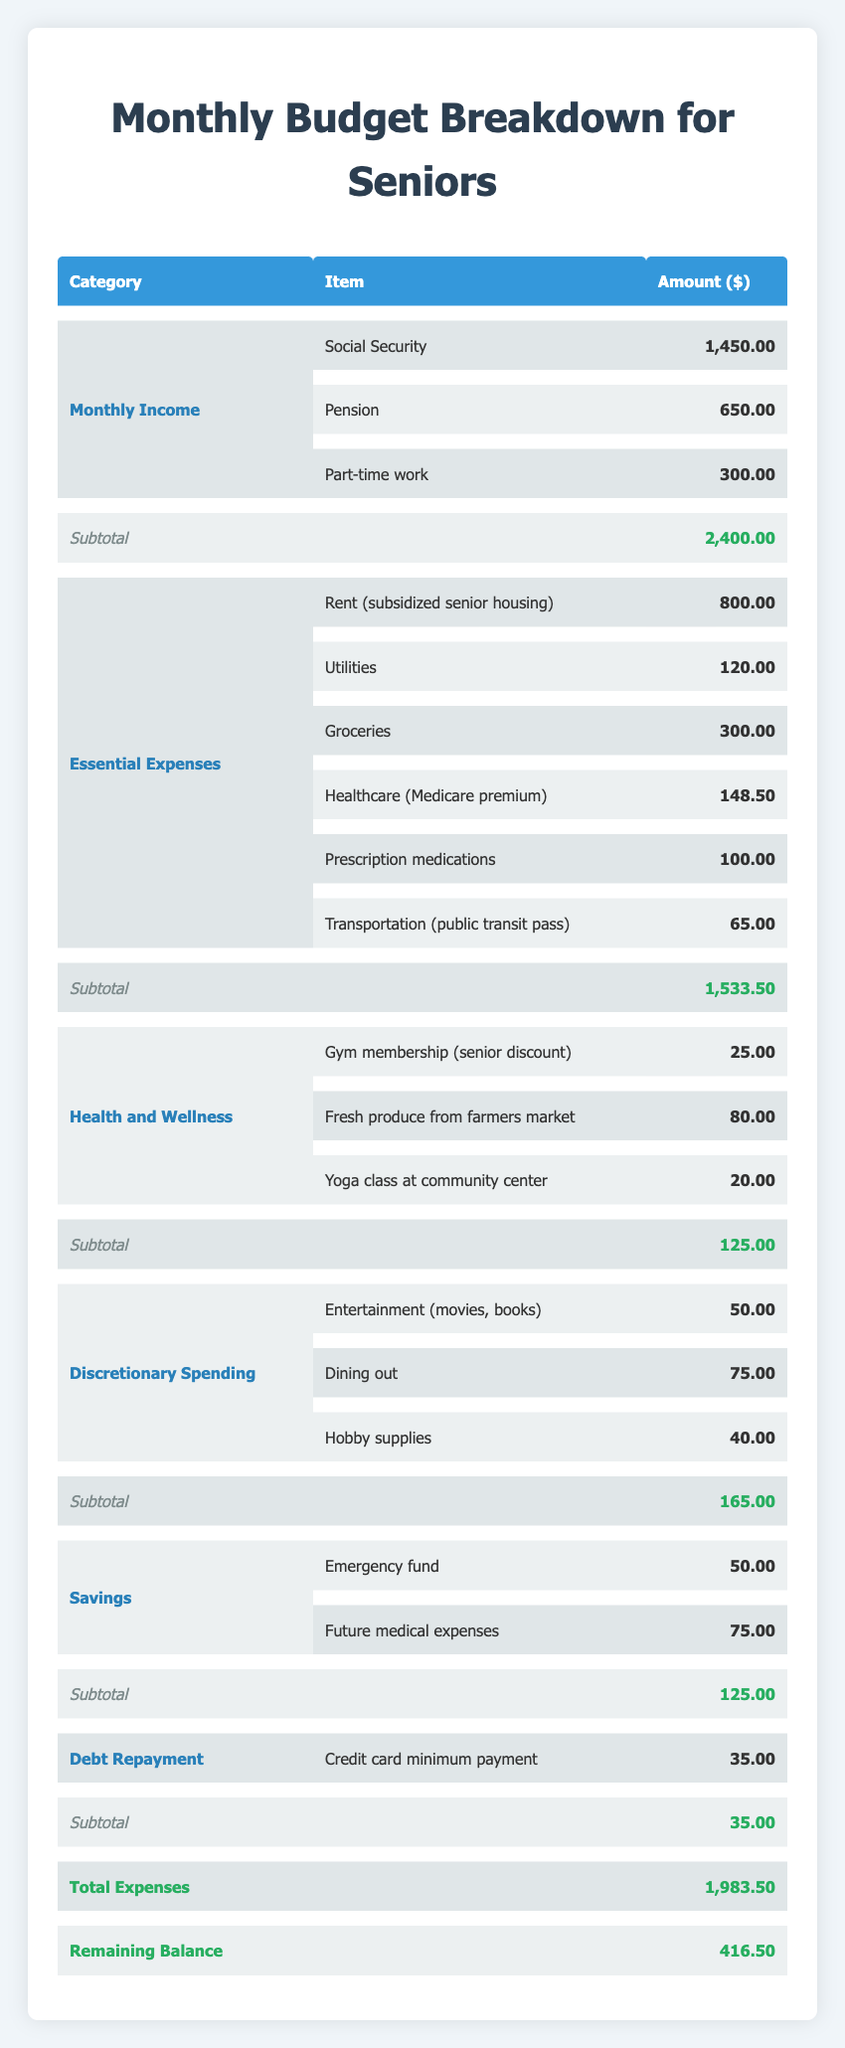What is the total monthly income? To find the total monthly income, we add the amounts from Social Security (1450), Pension (650), and Part-time work (300). Summing these gives us 1450 + 650 + 300 = 2400.
Answer: 2400 How much is spent on essential expenses? The essential expenses total is calculated by adding up the individual amounts: Rent (800) + Utilities (120) + Groceries (300) + Healthcare (148.50) + Prescription medications (100) + Transportation (65), which totals to 1533.50.
Answer: 1533.50 How much money is left after all expenses are deducted from the income? To find the remaining balance, subtract total expenses (1983.50) from total income (2400). The calculation is 2400 - 1983.50 = 416.50.
Answer: 416.50 Is the amount spent on health and wellness greater than the amount spent on discretionary spending? Health and wellness expenses total to 125 and discretionary spending totals 165. Since 125 is less than 165, the answer is no.
Answer: No What percentage of the total income is allocated to both savings categories? The total for savings is 125 (Emergency fund 50 + Future medical expenses 75), so to find the percentage of total income, we do (125 / 2400) * 100, which equals approximately 5.21%.
Answer: 5.21% How much more is spent on groceries compared to healthcare? We subtract the amount spent on healthcare (148.50) from the amount spent on groceries (300). The result is 300 - 148.50 = 151.50, indicating groceries are 151.50 more.
Answer: 151.50 If transportation costs were reduced by half, how would this affect the total expenses? The current transportation cost is 65. If reduced by half, it would be 65 / 2 = 32.50. We then replace the original expense in the total calculation: 1983.50 - 65 + 32.50 = 1951. The new total expenses would be 1951.
Answer: 1951 Is the total amount for debt repayment less than or equal to 50? The debt repayment total is 35, which is less than 50. Thus, the answer is yes.
Answer: Yes What is the difference between the total spending on essential expenses and health and wellness? Total essential expenses are 1533.50 and health and wellness is 125. The difference can be calculated by 1533.50 - 125 = 1408.50, indicating essential expenses are 1408.50 more.
Answer: 1408.50 